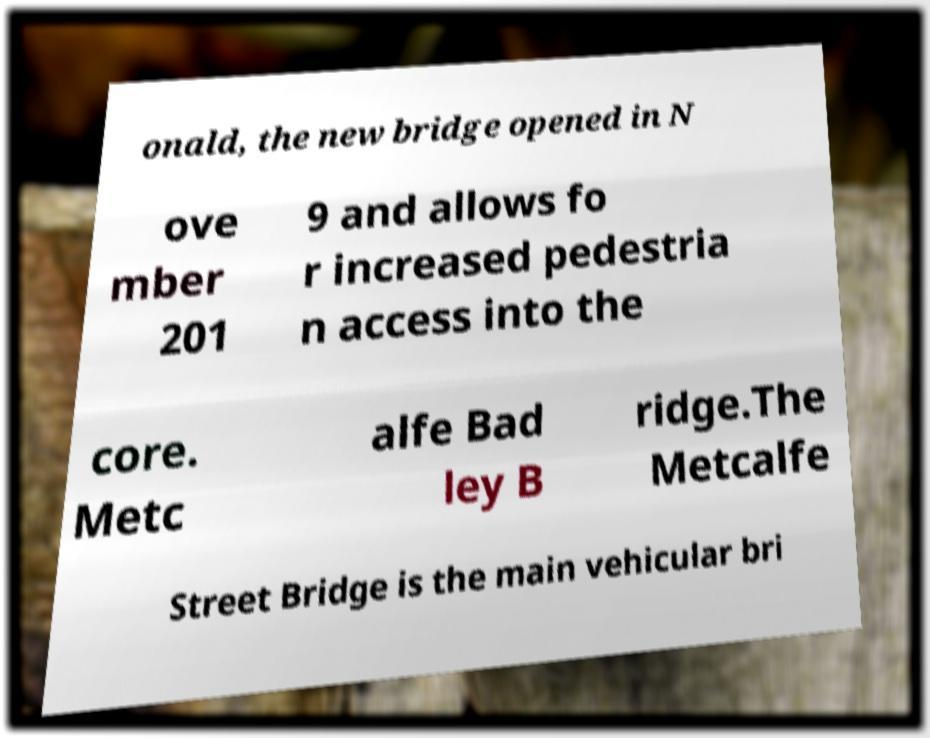Could you assist in decoding the text presented in this image and type it out clearly? onald, the new bridge opened in N ove mber 201 9 and allows fo r increased pedestria n access into the core. Metc alfe Bad ley B ridge.The Metcalfe Street Bridge is the main vehicular bri 